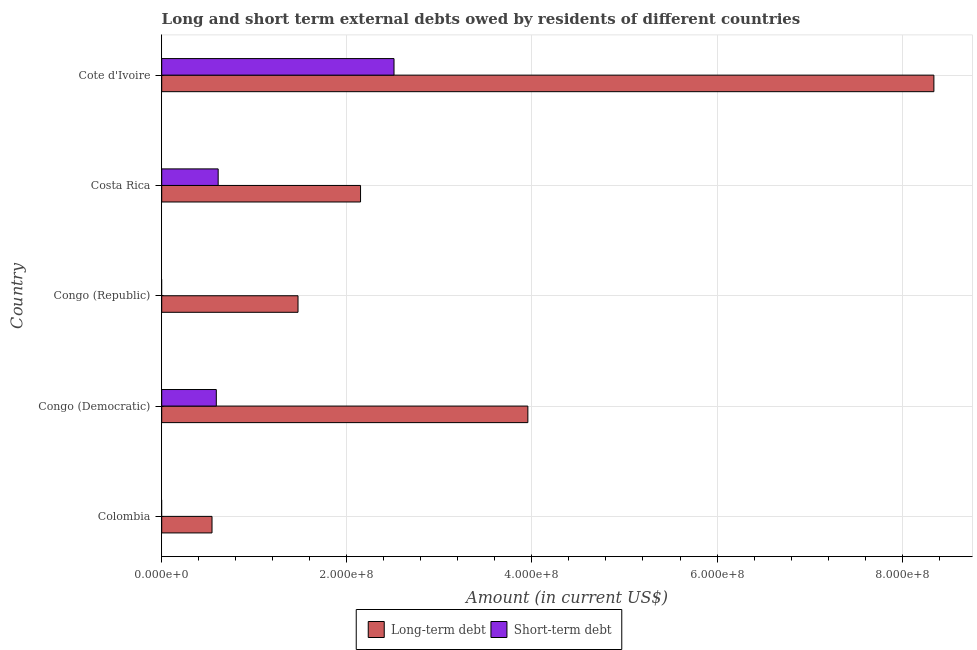How many different coloured bars are there?
Offer a terse response. 2. Are the number of bars on each tick of the Y-axis equal?
Give a very brief answer. No. What is the label of the 4th group of bars from the top?
Give a very brief answer. Congo (Democratic). In how many cases, is the number of bars for a given country not equal to the number of legend labels?
Your answer should be compact. 2. What is the short-term debts owed by residents in Congo (Republic)?
Your answer should be compact. 0. Across all countries, what is the maximum long-term debts owed by residents?
Your response must be concise. 8.34e+08. Across all countries, what is the minimum long-term debts owed by residents?
Ensure brevity in your answer.  5.44e+07. In which country was the long-term debts owed by residents maximum?
Give a very brief answer. Cote d'Ivoire. What is the total long-term debts owed by residents in the graph?
Your response must be concise. 1.65e+09. What is the difference between the long-term debts owed by residents in Congo (Republic) and that in Costa Rica?
Offer a terse response. -6.76e+07. What is the difference between the short-term debts owed by residents in Costa Rica and the long-term debts owed by residents in Congo (Democratic)?
Your response must be concise. -3.35e+08. What is the average long-term debts owed by residents per country?
Your response must be concise. 3.29e+08. What is the difference between the short-term debts owed by residents and long-term debts owed by residents in Congo (Democratic)?
Your answer should be compact. -3.37e+08. What is the ratio of the long-term debts owed by residents in Congo (Republic) to that in Cote d'Ivoire?
Your answer should be very brief. 0.18. Is the long-term debts owed by residents in Colombia less than that in Congo (Republic)?
Your answer should be compact. Yes. What is the difference between the highest and the second highest long-term debts owed by residents?
Keep it short and to the point. 4.39e+08. What is the difference between the highest and the lowest short-term debts owed by residents?
Provide a succinct answer. 2.51e+08. Is the sum of the long-term debts owed by residents in Congo (Democratic) and Congo (Republic) greater than the maximum short-term debts owed by residents across all countries?
Ensure brevity in your answer.  Yes. How many bars are there?
Your answer should be compact. 8. Are all the bars in the graph horizontal?
Offer a terse response. Yes. What is the difference between two consecutive major ticks on the X-axis?
Offer a very short reply. 2.00e+08. Are the values on the major ticks of X-axis written in scientific E-notation?
Keep it short and to the point. Yes. Where does the legend appear in the graph?
Give a very brief answer. Bottom center. How are the legend labels stacked?
Offer a terse response. Horizontal. What is the title of the graph?
Give a very brief answer. Long and short term external debts owed by residents of different countries. What is the label or title of the X-axis?
Provide a succinct answer. Amount (in current US$). What is the Amount (in current US$) of Long-term debt in Colombia?
Ensure brevity in your answer.  5.44e+07. What is the Amount (in current US$) in Short-term debt in Colombia?
Provide a succinct answer. 0. What is the Amount (in current US$) in Long-term debt in Congo (Democratic)?
Ensure brevity in your answer.  3.96e+08. What is the Amount (in current US$) of Short-term debt in Congo (Democratic)?
Offer a terse response. 5.90e+07. What is the Amount (in current US$) in Long-term debt in Congo (Republic)?
Make the answer very short. 1.47e+08. What is the Amount (in current US$) in Long-term debt in Costa Rica?
Ensure brevity in your answer.  2.15e+08. What is the Amount (in current US$) in Short-term debt in Costa Rica?
Provide a short and direct response. 6.10e+07. What is the Amount (in current US$) in Long-term debt in Cote d'Ivoire?
Keep it short and to the point. 8.34e+08. What is the Amount (in current US$) of Short-term debt in Cote d'Ivoire?
Your response must be concise. 2.51e+08. Across all countries, what is the maximum Amount (in current US$) in Long-term debt?
Your answer should be compact. 8.34e+08. Across all countries, what is the maximum Amount (in current US$) of Short-term debt?
Provide a succinct answer. 2.51e+08. Across all countries, what is the minimum Amount (in current US$) of Long-term debt?
Your answer should be compact. 5.44e+07. Across all countries, what is the minimum Amount (in current US$) of Short-term debt?
Your response must be concise. 0. What is the total Amount (in current US$) in Long-term debt in the graph?
Ensure brevity in your answer.  1.65e+09. What is the total Amount (in current US$) of Short-term debt in the graph?
Your answer should be compact. 3.71e+08. What is the difference between the Amount (in current US$) of Long-term debt in Colombia and that in Congo (Democratic)?
Your answer should be very brief. -3.41e+08. What is the difference between the Amount (in current US$) of Long-term debt in Colombia and that in Congo (Republic)?
Keep it short and to the point. -9.29e+07. What is the difference between the Amount (in current US$) in Long-term debt in Colombia and that in Costa Rica?
Your response must be concise. -1.60e+08. What is the difference between the Amount (in current US$) in Long-term debt in Colombia and that in Cote d'Ivoire?
Offer a terse response. -7.80e+08. What is the difference between the Amount (in current US$) of Long-term debt in Congo (Democratic) and that in Congo (Republic)?
Offer a terse response. 2.48e+08. What is the difference between the Amount (in current US$) in Long-term debt in Congo (Democratic) and that in Costa Rica?
Offer a very short reply. 1.81e+08. What is the difference between the Amount (in current US$) in Long-term debt in Congo (Democratic) and that in Cote d'Ivoire?
Give a very brief answer. -4.39e+08. What is the difference between the Amount (in current US$) in Short-term debt in Congo (Democratic) and that in Cote d'Ivoire?
Your response must be concise. -1.92e+08. What is the difference between the Amount (in current US$) in Long-term debt in Congo (Republic) and that in Costa Rica?
Your answer should be compact. -6.76e+07. What is the difference between the Amount (in current US$) in Long-term debt in Congo (Republic) and that in Cote d'Ivoire?
Provide a short and direct response. -6.87e+08. What is the difference between the Amount (in current US$) in Long-term debt in Costa Rica and that in Cote d'Ivoire?
Make the answer very short. -6.19e+08. What is the difference between the Amount (in current US$) of Short-term debt in Costa Rica and that in Cote d'Ivoire?
Your answer should be very brief. -1.90e+08. What is the difference between the Amount (in current US$) of Long-term debt in Colombia and the Amount (in current US$) of Short-term debt in Congo (Democratic)?
Provide a succinct answer. -4.64e+06. What is the difference between the Amount (in current US$) in Long-term debt in Colombia and the Amount (in current US$) in Short-term debt in Costa Rica?
Your response must be concise. -6.64e+06. What is the difference between the Amount (in current US$) in Long-term debt in Colombia and the Amount (in current US$) in Short-term debt in Cote d'Ivoire?
Provide a succinct answer. -1.97e+08. What is the difference between the Amount (in current US$) of Long-term debt in Congo (Democratic) and the Amount (in current US$) of Short-term debt in Costa Rica?
Provide a succinct answer. 3.35e+08. What is the difference between the Amount (in current US$) of Long-term debt in Congo (Democratic) and the Amount (in current US$) of Short-term debt in Cote d'Ivoire?
Offer a very short reply. 1.45e+08. What is the difference between the Amount (in current US$) of Long-term debt in Congo (Republic) and the Amount (in current US$) of Short-term debt in Costa Rica?
Ensure brevity in your answer.  8.63e+07. What is the difference between the Amount (in current US$) of Long-term debt in Congo (Republic) and the Amount (in current US$) of Short-term debt in Cote d'Ivoire?
Offer a very short reply. -1.04e+08. What is the difference between the Amount (in current US$) in Long-term debt in Costa Rica and the Amount (in current US$) in Short-term debt in Cote d'Ivoire?
Your answer should be compact. -3.62e+07. What is the average Amount (in current US$) of Long-term debt per country?
Your answer should be very brief. 3.29e+08. What is the average Amount (in current US$) in Short-term debt per country?
Keep it short and to the point. 7.42e+07. What is the difference between the Amount (in current US$) of Long-term debt and Amount (in current US$) of Short-term debt in Congo (Democratic)?
Your answer should be compact. 3.37e+08. What is the difference between the Amount (in current US$) in Long-term debt and Amount (in current US$) in Short-term debt in Costa Rica?
Offer a very short reply. 1.54e+08. What is the difference between the Amount (in current US$) of Long-term debt and Amount (in current US$) of Short-term debt in Cote d'Ivoire?
Your answer should be very brief. 5.83e+08. What is the ratio of the Amount (in current US$) in Long-term debt in Colombia to that in Congo (Democratic)?
Keep it short and to the point. 0.14. What is the ratio of the Amount (in current US$) of Long-term debt in Colombia to that in Congo (Republic)?
Your response must be concise. 0.37. What is the ratio of the Amount (in current US$) in Long-term debt in Colombia to that in Costa Rica?
Your answer should be very brief. 0.25. What is the ratio of the Amount (in current US$) of Long-term debt in Colombia to that in Cote d'Ivoire?
Offer a very short reply. 0.07. What is the ratio of the Amount (in current US$) in Long-term debt in Congo (Democratic) to that in Congo (Republic)?
Keep it short and to the point. 2.69. What is the ratio of the Amount (in current US$) of Long-term debt in Congo (Democratic) to that in Costa Rica?
Give a very brief answer. 1.84. What is the ratio of the Amount (in current US$) of Short-term debt in Congo (Democratic) to that in Costa Rica?
Provide a succinct answer. 0.97. What is the ratio of the Amount (in current US$) of Long-term debt in Congo (Democratic) to that in Cote d'Ivoire?
Your response must be concise. 0.47. What is the ratio of the Amount (in current US$) in Short-term debt in Congo (Democratic) to that in Cote d'Ivoire?
Ensure brevity in your answer.  0.24. What is the ratio of the Amount (in current US$) of Long-term debt in Congo (Republic) to that in Costa Rica?
Ensure brevity in your answer.  0.69. What is the ratio of the Amount (in current US$) in Long-term debt in Congo (Republic) to that in Cote d'Ivoire?
Your answer should be very brief. 0.18. What is the ratio of the Amount (in current US$) in Long-term debt in Costa Rica to that in Cote d'Ivoire?
Offer a very short reply. 0.26. What is the ratio of the Amount (in current US$) in Short-term debt in Costa Rica to that in Cote d'Ivoire?
Give a very brief answer. 0.24. What is the difference between the highest and the second highest Amount (in current US$) of Long-term debt?
Make the answer very short. 4.39e+08. What is the difference between the highest and the second highest Amount (in current US$) in Short-term debt?
Keep it short and to the point. 1.90e+08. What is the difference between the highest and the lowest Amount (in current US$) of Long-term debt?
Offer a very short reply. 7.80e+08. What is the difference between the highest and the lowest Amount (in current US$) in Short-term debt?
Offer a terse response. 2.51e+08. 